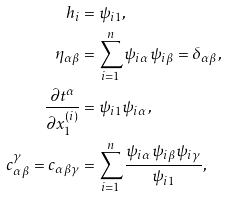<formula> <loc_0><loc_0><loc_500><loc_500>h _ { i } & = \psi _ { i 1 } , \\ \eta _ { \alpha \beta } & = \sum _ { i = 1 } ^ { n } \psi _ { i \alpha } \psi _ { i \beta } = \delta _ { \alpha \beta } , \\ \frac { \partial t ^ { \alpha } } { \partial x _ { 1 } ^ { ( i ) } } & = \psi _ { i 1 } \psi _ { i \alpha } , \\ c _ { \alpha \beta } ^ { \gamma } = c _ { \alpha \beta \gamma } & = \sum _ { i = 1 } ^ { n } \frac { \psi _ { i \alpha } \psi _ { i \beta } \psi _ { i \gamma } } { \psi _ { i 1 } } , \\</formula> 